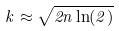Convert formula to latex. <formula><loc_0><loc_0><loc_500><loc_500>k \approx \sqrt { 2 n \ln ( 2 ) }</formula> 